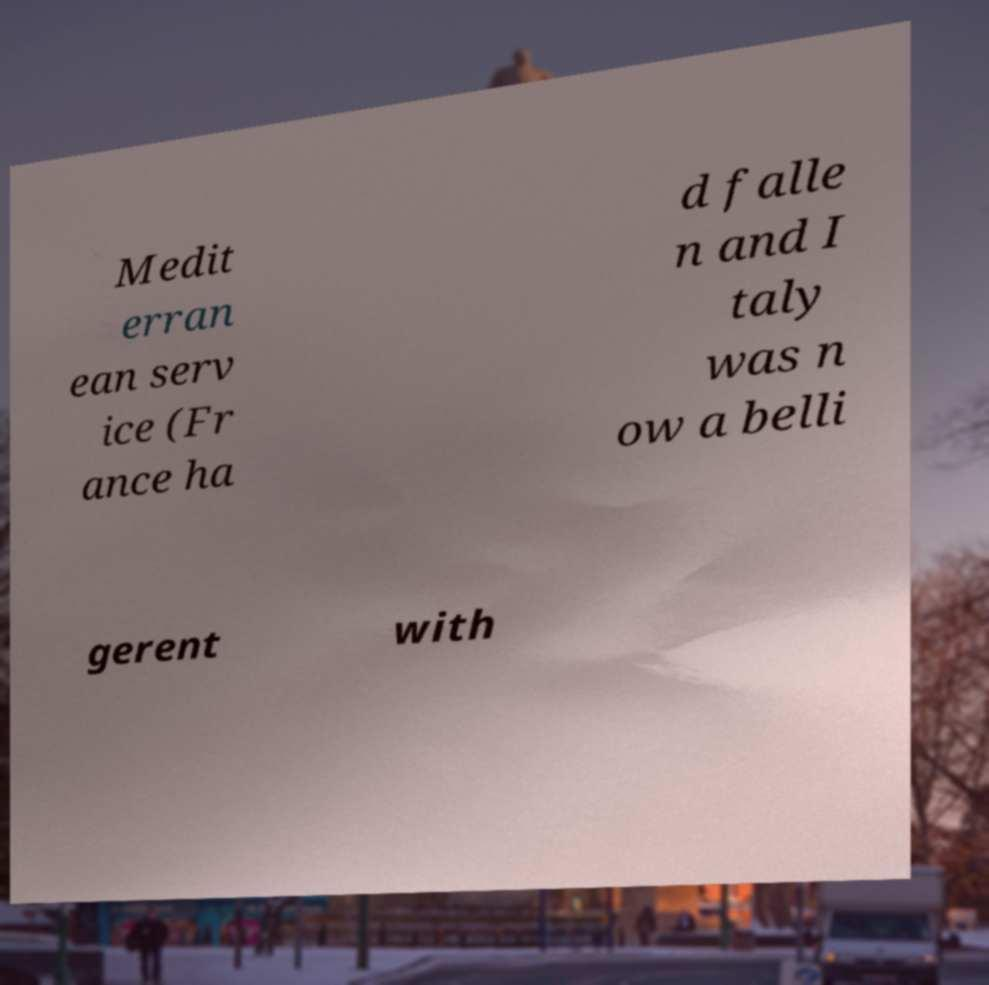What messages or text are displayed in this image? I need them in a readable, typed format. Medit erran ean serv ice (Fr ance ha d falle n and I taly was n ow a belli gerent with 